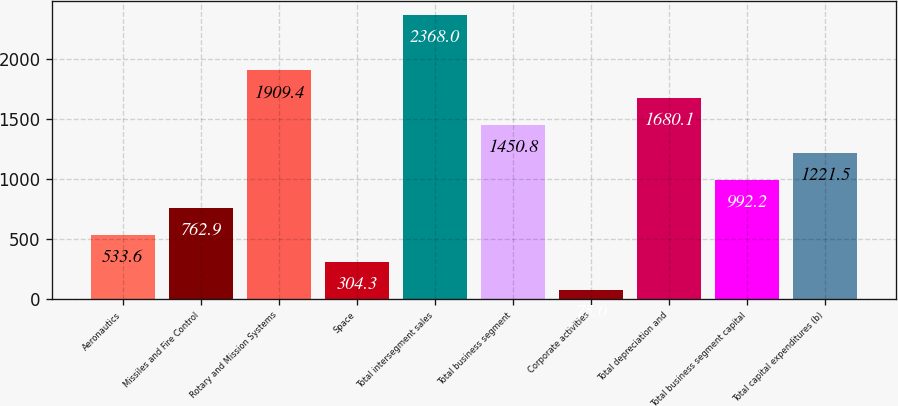<chart> <loc_0><loc_0><loc_500><loc_500><bar_chart><fcel>Aeronautics<fcel>Missiles and Fire Control<fcel>Rotary and Mission Systems<fcel>Space<fcel>Total intersegment sales<fcel>Total business segment<fcel>Corporate activities<fcel>Total depreciation and<fcel>Total business segment capital<fcel>Total capital expenditures (b)<nl><fcel>533.6<fcel>762.9<fcel>1909.4<fcel>304.3<fcel>2368<fcel>1450.8<fcel>75<fcel>1680.1<fcel>992.2<fcel>1221.5<nl></chart> 